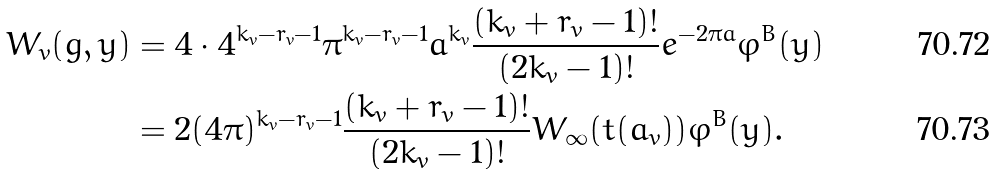Convert formula to latex. <formula><loc_0><loc_0><loc_500><loc_500>W _ { v } ( g , y ) & = 4 \cdot 4 ^ { k _ { v } - r _ { v } - 1 } \pi ^ { k _ { v } - r _ { v } - 1 } a ^ { k _ { v } } \frac { ( k _ { v } + r _ { v } - 1 ) ! } { ( 2 k _ { v } - 1 ) ! } e ^ { - 2 \pi a } \varphi ^ { B } ( y ) \\ & = 2 ( 4 \pi ) ^ { k _ { v } - r _ { v } - 1 } \frac { ( k _ { v } + r _ { v } - 1 ) ! } { ( 2 k _ { v } - 1 ) ! } W _ { \infty } ( t ( a _ { v } ) ) \varphi ^ { B } ( y ) .</formula> 